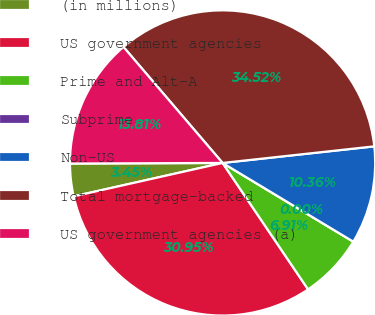Convert chart to OTSL. <chart><loc_0><loc_0><loc_500><loc_500><pie_chart><fcel>(in millions)<fcel>US government agencies<fcel>Prime and Alt-A<fcel>Subprime<fcel>Non-US<fcel>Total mortgage-backed<fcel>US government agencies (a)<nl><fcel>3.45%<fcel>30.95%<fcel>6.91%<fcel>0.0%<fcel>10.36%<fcel>34.52%<fcel>13.81%<nl></chart> 